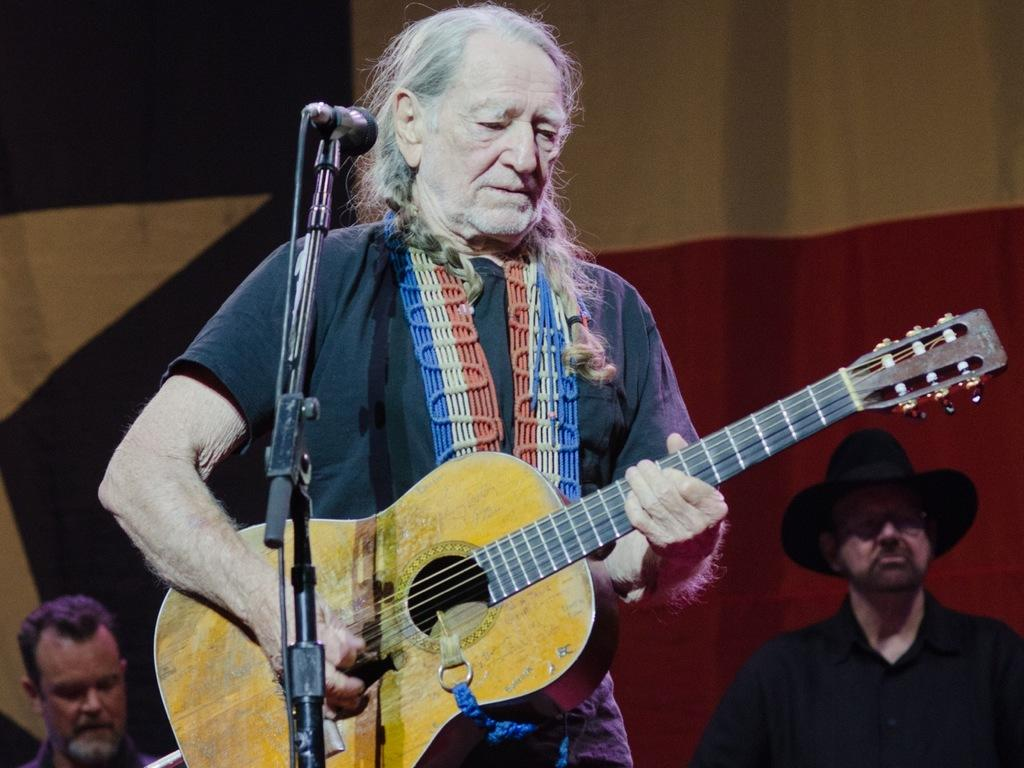Who is present in the image? There is a man in the image. What is the man doing in the image? The man is standing and holding a guitar in his hand. Can you describe the background of the image? There are people standing in the background of the image. What type of hook can be seen attached to the guitar in the image? There is no hook visible on the guitar in the image. 